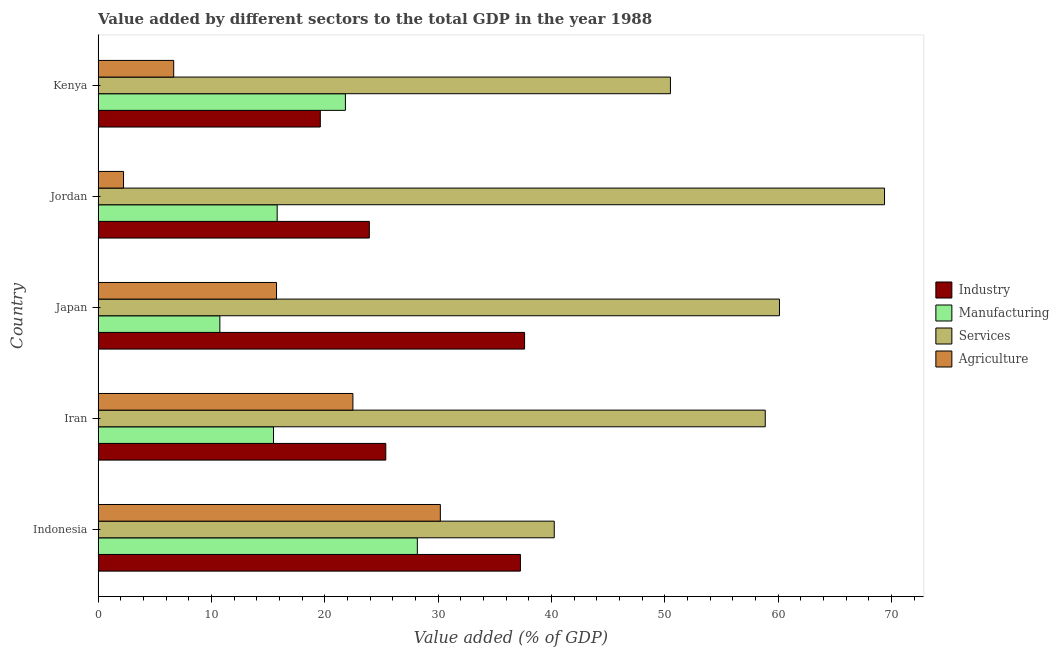How many different coloured bars are there?
Your response must be concise. 4. How many groups of bars are there?
Your answer should be compact. 5. Are the number of bars on each tick of the Y-axis equal?
Provide a short and direct response. Yes. How many bars are there on the 2nd tick from the top?
Give a very brief answer. 4. How many bars are there on the 5th tick from the bottom?
Offer a terse response. 4. What is the label of the 3rd group of bars from the top?
Your answer should be compact. Japan. What is the value added by manufacturing sector in Indonesia?
Provide a succinct answer. 28.17. Across all countries, what is the maximum value added by agricultural sector?
Ensure brevity in your answer.  30.2. Across all countries, what is the minimum value added by industrial sector?
Offer a terse response. 19.61. In which country was the value added by industrial sector maximum?
Give a very brief answer. Japan. In which country was the value added by agricultural sector minimum?
Provide a succinct answer. Jordan. What is the total value added by industrial sector in the graph?
Your answer should be compact. 143.82. What is the difference between the value added by manufacturing sector in Iran and that in Jordan?
Your answer should be very brief. -0.32. What is the difference between the value added by services sector in Japan and the value added by manufacturing sector in Indonesia?
Ensure brevity in your answer.  31.95. What is the average value added by agricultural sector per country?
Offer a terse response. 15.47. What is the difference between the value added by services sector and value added by industrial sector in Kenya?
Your answer should be compact. 30.9. What is the ratio of the value added by manufacturing sector in Indonesia to that in Jordan?
Provide a short and direct response. 1.78. What is the difference between the highest and the second highest value added by agricultural sector?
Your answer should be compact. 7.72. What is the difference between the highest and the lowest value added by industrial sector?
Your answer should be compact. 18.03. Is it the case that in every country, the sum of the value added by services sector and value added by manufacturing sector is greater than the sum of value added by agricultural sector and value added by industrial sector?
Make the answer very short. No. What does the 2nd bar from the top in Jordan represents?
Give a very brief answer. Services. What does the 2nd bar from the bottom in Kenya represents?
Offer a terse response. Manufacturing. Are all the bars in the graph horizontal?
Make the answer very short. Yes. Does the graph contain any zero values?
Make the answer very short. No. Where does the legend appear in the graph?
Make the answer very short. Center right. What is the title of the graph?
Give a very brief answer. Value added by different sectors to the total GDP in the year 1988. Does "Debt policy" appear as one of the legend labels in the graph?
Give a very brief answer. No. What is the label or title of the X-axis?
Your answer should be very brief. Value added (% of GDP). What is the label or title of the Y-axis?
Your answer should be very brief. Country. What is the Value added (% of GDP) in Industry in Indonesia?
Provide a short and direct response. 37.27. What is the Value added (% of GDP) in Manufacturing in Indonesia?
Make the answer very short. 28.17. What is the Value added (% of GDP) in Services in Indonesia?
Offer a very short reply. 40.25. What is the Value added (% of GDP) in Agriculture in Indonesia?
Provide a short and direct response. 30.2. What is the Value added (% of GDP) in Industry in Iran?
Offer a very short reply. 25.39. What is the Value added (% of GDP) in Manufacturing in Iran?
Your answer should be very brief. 15.48. What is the Value added (% of GDP) in Services in Iran?
Offer a terse response. 58.87. What is the Value added (% of GDP) of Agriculture in Iran?
Give a very brief answer. 22.48. What is the Value added (% of GDP) of Industry in Japan?
Your response must be concise. 37.63. What is the Value added (% of GDP) in Manufacturing in Japan?
Offer a terse response. 10.74. What is the Value added (% of GDP) of Services in Japan?
Make the answer very short. 60.12. What is the Value added (% of GDP) of Agriculture in Japan?
Make the answer very short. 15.74. What is the Value added (% of GDP) in Industry in Jordan?
Ensure brevity in your answer.  23.93. What is the Value added (% of GDP) in Manufacturing in Jordan?
Offer a terse response. 15.8. What is the Value added (% of GDP) in Services in Jordan?
Ensure brevity in your answer.  69.4. What is the Value added (% of GDP) of Agriculture in Jordan?
Provide a succinct answer. 2.24. What is the Value added (% of GDP) in Industry in Kenya?
Your answer should be very brief. 19.61. What is the Value added (% of GDP) in Manufacturing in Kenya?
Your answer should be very brief. 21.82. What is the Value added (% of GDP) in Services in Kenya?
Provide a succinct answer. 50.5. What is the Value added (% of GDP) in Agriculture in Kenya?
Your answer should be very brief. 6.67. Across all countries, what is the maximum Value added (% of GDP) of Industry?
Your answer should be compact. 37.63. Across all countries, what is the maximum Value added (% of GDP) in Manufacturing?
Your answer should be very brief. 28.17. Across all countries, what is the maximum Value added (% of GDP) of Services?
Give a very brief answer. 69.4. Across all countries, what is the maximum Value added (% of GDP) of Agriculture?
Offer a very short reply. 30.2. Across all countries, what is the minimum Value added (% of GDP) of Industry?
Keep it short and to the point. 19.61. Across all countries, what is the minimum Value added (% of GDP) in Manufacturing?
Provide a succinct answer. 10.74. Across all countries, what is the minimum Value added (% of GDP) of Services?
Provide a short and direct response. 40.25. Across all countries, what is the minimum Value added (% of GDP) in Agriculture?
Your response must be concise. 2.24. What is the total Value added (% of GDP) of Industry in the graph?
Make the answer very short. 143.82. What is the total Value added (% of GDP) in Manufacturing in the graph?
Give a very brief answer. 92.01. What is the total Value added (% of GDP) in Services in the graph?
Offer a very short reply. 279.15. What is the total Value added (% of GDP) of Agriculture in the graph?
Your answer should be very brief. 77.34. What is the difference between the Value added (% of GDP) of Industry in Indonesia and that in Iran?
Ensure brevity in your answer.  11.88. What is the difference between the Value added (% of GDP) of Manufacturing in Indonesia and that in Iran?
Keep it short and to the point. 12.69. What is the difference between the Value added (% of GDP) of Services in Indonesia and that in Iran?
Your response must be concise. -18.62. What is the difference between the Value added (% of GDP) of Agriculture in Indonesia and that in Iran?
Provide a short and direct response. 7.72. What is the difference between the Value added (% of GDP) of Industry in Indonesia and that in Japan?
Offer a very short reply. -0.37. What is the difference between the Value added (% of GDP) in Manufacturing in Indonesia and that in Japan?
Your answer should be compact. 17.43. What is the difference between the Value added (% of GDP) in Services in Indonesia and that in Japan?
Offer a very short reply. -19.87. What is the difference between the Value added (% of GDP) in Agriculture in Indonesia and that in Japan?
Offer a very short reply. 14.46. What is the difference between the Value added (% of GDP) in Industry in Indonesia and that in Jordan?
Ensure brevity in your answer.  13.33. What is the difference between the Value added (% of GDP) in Manufacturing in Indonesia and that in Jordan?
Your response must be concise. 12.37. What is the difference between the Value added (% of GDP) of Services in Indonesia and that in Jordan?
Offer a terse response. -29.15. What is the difference between the Value added (% of GDP) of Agriculture in Indonesia and that in Jordan?
Your answer should be very brief. 27.96. What is the difference between the Value added (% of GDP) in Industry in Indonesia and that in Kenya?
Give a very brief answer. 17.66. What is the difference between the Value added (% of GDP) in Manufacturing in Indonesia and that in Kenya?
Keep it short and to the point. 6.35. What is the difference between the Value added (% of GDP) of Services in Indonesia and that in Kenya?
Offer a terse response. -10.25. What is the difference between the Value added (% of GDP) of Agriculture in Indonesia and that in Kenya?
Provide a short and direct response. 23.53. What is the difference between the Value added (% of GDP) of Industry in Iran and that in Japan?
Your answer should be compact. -12.25. What is the difference between the Value added (% of GDP) of Manufacturing in Iran and that in Japan?
Your answer should be compact. 4.73. What is the difference between the Value added (% of GDP) of Services in Iran and that in Japan?
Offer a terse response. -1.25. What is the difference between the Value added (% of GDP) in Agriculture in Iran and that in Japan?
Your answer should be very brief. 6.74. What is the difference between the Value added (% of GDP) of Industry in Iran and that in Jordan?
Make the answer very short. 1.45. What is the difference between the Value added (% of GDP) in Manufacturing in Iran and that in Jordan?
Offer a very short reply. -0.32. What is the difference between the Value added (% of GDP) of Services in Iran and that in Jordan?
Offer a very short reply. -10.53. What is the difference between the Value added (% of GDP) in Agriculture in Iran and that in Jordan?
Provide a succinct answer. 20.24. What is the difference between the Value added (% of GDP) in Industry in Iran and that in Kenya?
Your answer should be compact. 5.78. What is the difference between the Value added (% of GDP) in Manufacturing in Iran and that in Kenya?
Keep it short and to the point. -6.34. What is the difference between the Value added (% of GDP) of Services in Iran and that in Kenya?
Offer a very short reply. 8.37. What is the difference between the Value added (% of GDP) of Agriculture in Iran and that in Kenya?
Offer a very short reply. 15.81. What is the difference between the Value added (% of GDP) in Industry in Japan and that in Jordan?
Ensure brevity in your answer.  13.7. What is the difference between the Value added (% of GDP) of Manufacturing in Japan and that in Jordan?
Provide a succinct answer. -5.06. What is the difference between the Value added (% of GDP) in Services in Japan and that in Jordan?
Provide a short and direct response. -9.27. What is the difference between the Value added (% of GDP) of Agriculture in Japan and that in Jordan?
Give a very brief answer. 13.5. What is the difference between the Value added (% of GDP) in Industry in Japan and that in Kenya?
Keep it short and to the point. 18.03. What is the difference between the Value added (% of GDP) of Manufacturing in Japan and that in Kenya?
Give a very brief answer. -11.08. What is the difference between the Value added (% of GDP) in Services in Japan and that in Kenya?
Provide a short and direct response. 9.62. What is the difference between the Value added (% of GDP) in Agriculture in Japan and that in Kenya?
Make the answer very short. 9.07. What is the difference between the Value added (% of GDP) of Industry in Jordan and that in Kenya?
Give a very brief answer. 4.33. What is the difference between the Value added (% of GDP) in Manufacturing in Jordan and that in Kenya?
Give a very brief answer. -6.02. What is the difference between the Value added (% of GDP) of Services in Jordan and that in Kenya?
Keep it short and to the point. 18.89. What is the difference between the Value added (% of GDP) in Agriculture in Jordan and that in Kenya?
Your answer should be very brief. -4.43. What is the difference between the Value added (% of GDP) of Industry in Indonesia and the Value added (% of GDP) of Manufacturing in Iran?
Your answer should be compact. 21.79. What is the difference between the Value added (% of GDP) in Industry in Indonesia and the Value added (% of GDP) in Services in Iran?
Your response must be concise. -21.6. What is the difference between the Value added (% of GDP) in Industry in Indonesia and the Value added (% of GDP) in Agriculture in Iran?
Your answer should be very brief. 14.78. What is the difference between the Value added (% of GDP) of Manufacturing in Indonesia and the Value added (% of GDP) of Services in Iran?
Give a very brief answer. -30.7. What is the difference between the Value added (% of GDP) of Manufacturing in Indonesia and the Value added (% of GDP) of Agriculture in Iran?
Provide a short and direct response. 5.69. What is the difference between the Value added (% of GDP) in Services in Indonesia and the Value added (% of GDP) in Agriculture in Iran?
Your response must be concise. 17.77. What is the difference between the Value added (% of GDP) of Industry in Indonesia and the Value added (% of GDP) of Manufacturing in Japan?
Provide a short and direct response. 26.52. What is the difference between the Value added (% of GDP) in Industry in Indonesia and the Value added (% of GDP) in Services in Japan?
Your answer should be very brief. -22.86. What is the difference between the Value added (% of GDP) of Industry in Indonesia and the Value added (% of GDP) of Agriculture in Japan?
Offer a terse response. 21.52. What is the difference between the Value added (% of GDP) in Manufacturing in Indonesia and the Value added (% of GDP) in Services in Japan?
Make the answer very short. -31.95. What is the difference between the Value added (% of GDP) in Manufacturing in Indonesia and the Value added (% of GDP) in Agriculture in Japan?
Keep it short and to the point. 12.43. What is the difference between the Value added (% of GDP) of Services in Indonesia and the Value added (% of GDP) of Agriculture in Japan?
Offer a terse response. 24.51. What is the difference between the Value added (% of GDP) of Industry in Indonesia and the Value added (% of GDP) of Manufacturing in Jordan?
Your response must be concise. 21.47. What is the difference between the Value added (% of GDP) in Industry in Indonesia and the Value added (% of GDP) in Services in Jordan?
Your response must be concise. -32.13. What is the difference between the Value added (% of GDP) in Industry in Indonesia and the Value added (% of GDP) in Agriculture in Jordan?
Your response must be concise. 35.02. What is the difference between the Value added (% of GDP) in Manufacturing in Indonesia and the Value added (% of GDP) in Services in Jordan?
Make the answer very short. -41.23. What is the difference between the Value added (% of GDP) in Manufacturing in Indonesia and the Value added (% of GDP) in Agriculture in Jordan?
Make the answer very short. 25.93. What is the difference between the Value added (% of GDP) in Services in Indonesia and the Value added (% of GDP) in Agriculture in Jordan?
Provide a succinct answer. 38.01. What is the difference between the Value added (% of GDP) in Industry in Indonesia and the Value added (% of GDP) in Manufacturing in Kenya?
Provide a short and direct response. 15.44. What is the difference between the Value added (% of GDP) of Industry in Indonesia and the Value added (% of GDP) of Services in Kenya?
Your answer should be compact. -13.24. What is the difference between the Value added (% of GDP) in Industry in Indonesia and the Value added (% of GDP) in Agriculture in Kenya?
Ensure brevity in your answer.  30.6. What is the difference between the Value added (% of GDP) of Manufacturing in Indonesia and the Value added (% of GDP) of Services in Kenya?
Provide a succinct answer. -22.33. What is the difference between the Value added (% of GDP) of Manufacturing in Indonesia and the Value added (% of GDP) of Agriculture in Kenya?
Provide a short and direct response. 21.5. What is the difference between the Value added (% of GDP) in Services in Indonesia and the Value added (% of GDP) in Agriculture in Kenya?
Offer a very short reply. 33.58. What is the difference between the Value added (% of GDP) of Industry in Iran and the Value added (% of GDP) of Manufacturing in Japan?
Your response must be concise. 14.64. What is the difference between the Value added (% of GDP) of Industry in Iran and the Value added (% of GDP) of Services in Japan?
Offer a very short reply. -34.74. What is the difference between the Value added (% of GDP) in Industry in Iran and the Value added (% of GDP) in Agriculture in Japan?
Make the answer very short. 9.64. What is the difference between the Value added (% of GDP) of Manufacturing in Iran and the Value added (% of GDP) of Services in Japan?
Offer a terse response. -44.65. What is the difference between the Value added (% of GDP) in Manufacturing in Iran and the Value added (% of GDP) in Agriculture in Japan?
Offer a very short reply. -0.27. What is the difference between the Value added (% of GDP) in Services in Iran and the Value added (% of GDP) in Agriculture in Japan?
Make the answer very short. 43.13. What is the difference between the Value added (% of GDP) in Industry in Iran and the Value added (% of GDP) in Manufacturing in Jordan?
Your answer should be compact. 9.58. What is the difference between the Value added (% of GDP) of Industry in Iran and the Value added (% of GDP) of Services in Jordan?
Give a very brief answer. -44.01. What is the difference between the Value added (% of GDP) in Industry in Iran and the Value added (% of GDP) in Agriculture in Jordan?
Your answer should be very brief. 23.14. What is the difference between the Value added (% of GDP) of Manufacturing in Iran and the Value added (% of GDP) of Services in Jordan?
Your answer should be very brief. -53.92. What is the difference between the Value added (% of GDP) in Manufacturing in Iran and the Value added (% of GDP) in Agriculture in Jordan?
Make the answer very short. 13.23. What is the difference between the Value added (% of GDP) of Services in Iran and the Value added (% of GDP) of Agriculture in Jordan?
Make the answer very short. 56.63. What is the difference between the Value added (% of GDP) of Industry in Iran and the Value added (% of GDP) of Manufacturing in Kenya?
Ensure brevity in your answer.  3.56. What is the difference between the Value added (% of GDP) of Industry in Iran and the Value added (% of GDP) of Services in Kenya?
Provide a succinct answer. -25.12. What is the difference between the Value added (% of GDP) in Industry in Iran and the Value added (% of GDP) in Agriculture in Kenya?
Give a very brief answer. 18.71. What is the difference between the Value added (% of GDP) of Manufacturing in Iran and the Value added (% of GDP) of Services in Kenya?
Your answer should be compact. -35.03. What is the difference between the Value added (% of GDP) of Manufacturing in Iran and the Value added (% of GDP) of Agriculture in Kenya?
Your answer should be compact. 8.81. What is the difference between the Value added (% of GDP) of Services in Iran and the Value added (% of GDP) of Agriculture in Kenya?
Provide a succinct answer. 52.2. What is the difference between the Value added (% of GDP) in Industry in Japan and the Value added (% of GDP) in Manufacturing in Jordan?
Your response must be concise. 21.83. What is the difference between the Value added (% of GDP) of Industry in Japan and the Value added (% of GDP) of Services in Jordan?
Provide a succinct answer. -31.76. What is the difference between the Value added (% of GDP) of Industry in Japan and the Value added (% of GDP) of Agriculture in Jordan?
Keep it short and to the point. 35.39. What is the difference between the Value added (% of GDP) of Manufacturing in Japan and the Value added (% of GDP) of Services in Jordan?
Provide a short and direct response. -58.65. What is the difference between the Value added (% of GDP) in Manufacturing in Japan and the Value added (% of GDP) in Agriculture in Jordan?
Make the answer very short. 8.5. What is the difference between the Value added (% of GDP) of Services in Japan and the Value added (% of GDP) of Agriculture in Jordan?
Provide a succinct answer. 57.88. What is the difference between the Value added (% of GDP) in Industry in Japan and the Value added (% of GDP) in Manufacturing in Kenya?
Your response must be concise. 15.81. What is the difference between the Value added (% of GDP) of Industry in Japan and the Value added (% of GDP) of Services in Kenya?
Provide a short and direct response. -12.87. What is the difference between the Value added (% of GDP) of Industry in Japan and the Value added (% of GDP) of Agriculture in Kenya?
Provide a short and direct response. 30.96. What is the difference between the Value added (% of GDP) in Manufacturing in Japan and the Value added (% of GDP) in Services in Kenya?
Offer a terse response. -39.76. What is the difference between the Value added (% of GDP) of Manufacturing in Japan and the Value added (% of GDP) of Agriculture in Kenya?
Your answer should be compact. 4.07. What is the difference between the Value added (% of GDP) of Services in Japan and the Value added (% of GDP) of Agriculture in Kenya?
Give a very brief answer. 53.45. What is the difference between the Value added (% of GDP) in Industry in Jordan and the Value added (% of GDP) in Manufacturing in Kenya?
Your answer should be very brief. 2.11. What is the difference between the Value added (% of GDP) of Industry in Jordan and the Value added (% of GDP) of Services in Kenya?
Keep it short and to the point. -26.57. What is the difference between the Value added (% of GDP) of Industry in Jordan and the Value added (% of GDP) of Agriculture in Kenya?
Ensure brevity in your answer.  17.26. What is the difference between the Value added (% of GDP) in Manufacturing in Jordan and the Value added (% of GDP) in Services in Kenya?
Ensure brevity in your answer.  -34.7. What is the difference between the Value added (% of GDP) in Manufacturing in Jordan and the Value added (% of GDP) in Agriculture in Kenya?
Your response must be concise. 9.13. What is the difference between the Value added (% of GDP) of Services in Jordan and the Value added (% of GDP) of Agriculture in Kenya?
Ensure brevity in your answer.  62.73. What is the average Value added (% of GDP) of Industry per country?
Your answer should be compact. 28.76. What is the average Value added (% of GDP) in Manufacturing per country?
Ensure brevity in your answer.  18.4. What is the average Value added (% of GDP) in Services per country?
Provide a succinct answer. 55.83. What is the average Value added (% of GDP) in Agriculture per country?
Your response must be concise. 15.47. What is the difference between the Value added (% of GDP) in Industry and Value added (% of GDP) in Manufacturing in Indonesia?
Make the answer very short. 9.1. What is the difference between the Value added (% of GDP) of Industry and Value added (% of GDP) of Services in Indonesia?
Offer a terse response. -2.98. What is the difference between the Value added (% of GDP) of Industry and Value added (% of GDP) of Agriculture in Indonesia?
Your response must be concise. 7.07. What is the difference between the Value added (% of GDP) of Manufacturing and Value added (% of GDP) of Services in Indonesia?
Your answer should be compact. -12.08. What is the difference between the Value added (% of GDP) of Manufacturing and Value added (% of GDP) of Agriculture in Indonesia?
Your answer should be very brief. -2.03. What is the difference between the Value added (% of GDP) in Services and Value added (% of GDP) in Agriculture in Indonesia?
Ensure brevity in your answer.  10.05. What is the difference between the Value added (% of GDP) of Industry and Value added (% of GDP) of Manufacturing in Iran?
Offer a very short reply. 9.91. What is the difference between the Value added (% of GDP) in Industry and Value added (% of GDP) in Services in Iran?
Offer a very short reply. -33.49. What is the difference between the Value added (% of GDP) of Industry and Value added (% of GDP) of Agriculture in Iran?
Offer a very short reply. 2.9. What is the difference between the Value added (% of GDP) of Manufacturing and Value added (% of GDP) of Services in Iran?
Provide a succinct answer. -43.39. What is the difference between the Value added (% of GDP) in Manufacturing and Value added (% of GDP) in Agriculture in Iran?
Give a very brief answer. -7.01. What is the difference between the Value added (% of GDP) in Services and Value added (% of GDP) in Agriculture in Iran?
Your response must be concise. 36.39. What is the difference between the Value added (% of GDP) of Industry and Value added (% of GDP) of Manufacturing in Japan?
Give a very brief answer. 26.89. What is the difference between the Value added (% of GDP) in Industry and Value added (% of GDP) in Services in Japan?
Your response must be concise. -22.49. What is the difference between the Value added (% of GDP) in Industry and Value added (% of GDP) in Agriculture in Japan?
Provide a short and direct response. 21.89. What is the difference between the Value added (% of GDP) of Manufacturing and Value added (% of GDP) of Services in Japan?
Provide a short and direct response. -49.38. What is the difference between the Value added (% of GDP) of Manufacturing and Value added (% of GDP) of Agriculture in Japan?
Ensure brevity in your answer.  -5. What is the difference between the Value added (% of GDP) in Services and Value added (% of GDP) in Agriculture in Japan?
Provide a succinct answer. 44.38. What is the difference between the Value added (% of GDP) in Industry and Value added (% of GDP) in Manufacturing in Jordan?
Make the answer very short. 8.13. What is the difference between the Value added (% of GDP) of Industry and Value added (% of GDP) of Services in Jordan?
Make the answer very short. -45.46. What is the difference between the Value added (% of GDP) in Industry and Value added (% of GDP) in Agriculture in Jordan?
Ensure brevity in your answer.  21.69. What is the difference between the Value added (% of GDP) in Manufacturing and Value added (% of GDP) in Services in Jordan?
Provide a short and direct response. -53.6. What is the difference between the Value added (% of GDP) of Manufacturing and Value added (% of GDP) of Agriculture in Jordan?
Your answer should be very brief. 13.56. What is the difference between the Value added (% of GDP) in Services and Value added (% of GDP) in Agriculture in Jordan?
Offer a terse response. 67.15. What is the difference between the Value added (% of GDP) in Industry and Value added (% of GDP) in Manufacturing in Kenya?
Give a very brief answer. -2.22. What is the difference between the Value added (% of GDP) in Industry and Value added (% of GDP) in Services in Kenya?
Offer a very short reply. -30.9. What is the difference between the Value added (% of GDP) of Industry and Value added (% of GDP) of Agriculture in Kenya?
Your response must be concise. 12.94. What is the difference between the Value added (% of GDP) in Manufacturing and Value added (% of GDP) in Services in Kenya?
Offer a terse response. -28.68. What is the difference between the Value added (% of GDP) in Manufacturing and Value added (% of GDP) in Agriculture in Kenya?
Provide a succinct answer. 15.15. What is the difference between the Value added (% of GDP) of Services and Value added (% of GDP) of Agriculture in Kenya?
Provide a short and direct response. 43.83. What is the ratio of the Value added (% of GDP) in Industry in Indonesia to that in Iran?
Offer a very short reply. 1.47. What is the ratio of the Value added (% of GDP) in Manufacturing in Indonesia to that in Iran?
Provide a short and direct response. 1.82. What is the ratio of the Value added (% of GDP) in Services in Indonesia to that in Iran?
Provide a short and direct response. 0.68. What is the ratio of the Value added (% of GDP) of Agriculture in Indonesia to that in Iran?
Ensure brevity in your answer.  1.34. What is the ratio of the Value added (% of GDP) in Industry in Indonesia to that in Japan?
Ensure brevity in your answer.  0.99. What is the ratio of the Value added (% of GDP) of Manufacturing in Indonesia to that in Japan?
Offer a very short reply. 2.62. What is the ratio of the Value added (% of GDP) of Services in Indonesia to that in Japan?
Your answer should be very brief. 0.67. What is the ratio of the Value added (% of GDP) in Agriculture in Indonesia to that in Japan?
Your answer should be very brief. 1.92. What is the ratio of the Value added (% of GDP) of Industry in Indonesia to that in Jordan?
Provide a succinct answer. 1.56. What is the ratio of the Value added (% of GDP) in Manufacturing in Indonesia to that in Jordan?
Offer a very short reply. 1.78. What is the ratio of the Value added (% of GDP) of Services in Indonesia to that in Jordan?
Your response must be concise. 0.58. What is the ratio of the Value added (% of GDP) of Agriculture in Indonesia to that in Jordan?
Offer a terse response. 13.47. What is the ratio of the Value added (% of GDP) in Industry in Indonesia to that in Kenya?
Give a very brief answer. 1.9. What is the ratio of the Value added (% of GDP) of Manufacturing in Indonesia to that in Kenya?
Your answer should be compact. 1.29. What is the ratio of the Value added (% of GDP) of Services in Indonesia to that in Kenya?
Give a very brief answer. 0.8. What is the ratio of the Value added (% of GDP) of Agriculture in Indonesia to that in Kenya?
Make the answer very short. 4.53. What is the ratio of the Value added (% of GDP) in Industry in Iran to that in Japan?
Make the answer very short. 0.67. What is the ratio of the Value added (% of GDP) of Manufacturing in Iran to that in Japan?
Give a very brief answer. 1.44. What is the ratio of the Value added (% of GDP) in Services in Iran to that in Japan?
Offer a terse response. 0.98. What is the ratio of the Value added (% of GDP) in Agriculture in Iran to that in Japan?
Provide a succinct answer. 1.43. What is the ratio of the Value added (% of GDP) of Industry in Iran to that in Jordan?
Keep it short and to the point. 1.06. What is the ratio of the Value added (% of GDP) of Manufacturing in Iran to that in Jordan?
Ensure brevity in your answer.  0.98. What is the ratio of the Value added (% of GDP) of Services in Iran to that in Jordan?
Ensure brevity in your answer.  0.85. What is the ratio of the Value added (% of GDP) of Agriculture in Iran to that in Jordan?
Your response must be concise. 10.03. What is the ratio of the Value added (% of GDP) of Industry in Iran to that in Kenya?
Keep it short and to the point. 1.29. What is the ratio of the Value added (% of GDP) in Manufacturing in Iran to that in Kenya?
Keep it short and to the point. 0.71. What is the ratio of the Value added (% of GDP) of Services in Iran to that in Kenya?
Your answer should be very brief. 1.17. What is the ratio of the Value added (% of GDP) in Agriculture in Iran to that in Kenya?
Provide a short and direct response. 3.37. What is the ratio of the Value added (% of GDP) of Industry in Japan to that in Jordan?
Make the answer very short. 1.57. What is the ratio of the Value added (% of GDP) of Manufacturing in Japan to that in Jordan?
Your response must be concise. 0.68. What is the ratio of the Value added (% of GDP) of Services in Japan to that in Jordan?
Give a very brief answer. 0.87. What is the ratio of the Value added (% of GDP) of Agriculture in Japan to that in Jordan?
Offer a very short reply. 7.02. What is the ratio of the Value added (% of GDP) in Industry in Japan to that in Kenya?
Offer a very short reply. 1.92. What is the ratio of the Value added (% of GDP) in Manufacturing in Japan to that in Kenya?
Provide a short and direct response. 0.49. What is the ratio of the Value added (% of GDP) in Services in Japan to that in Kenya?
Keep it short and to the point. 1.19. What is the ratio of the Value added (% of GDP) of Agriculture in Japan to that in Kenya?
Your answer should be compact. 2.36. What is the ratio of the Value added (% of GDP) in Industry in Jordan to that in Kenya?
Make the answer very short. 1.22. What is the ratio of the Value added (% of GDP) in Manufacturing in Jordan to that in Kenya?
Your answer should be very brief. 0.72. What is the ratio of the Value added (% of GDP) in Services in Jordan to that in Kenya?
Offer a very short reply. 1.37. What is the ratio of the Value added (% of GDP) of Agriculture in Jordan to that in Kenya?
Your response must be concise. 0.34. What is the difference between the highest and the second highest Value added (% of GDP) of Industry?
Ensure brevity in your answer.  0.37. What is the difference between the highest and the second highest Value added (% of GDP) of Manufacturing?
Keep it short and to the point. 6.35. What is the difference between the highest and the second highest Value added (% of GDP) of Services?
Your response must be concise. 9.27. What is the difference between the highest and the second highest Value added (% of GDP) in Agriculture?
Provide a short and direct response. 7.72. What is the difference between the highest and the lowest Value added (% of GDP) of Industry?
Your answer should be compact. 18.03. What is the difference between the highest and the lowest Value added (% of GDP) in Manufacturing?
Your answer should be very brief. 17.43. What is the difference between the highest and the lowest Value added (% of GDP) in Services?
Your answer should be very brief. 29.15. What is the difference between the highest and the lowest Value added (% of GDP) of Agriculture?
Provide a short and direct response. 27.96. 